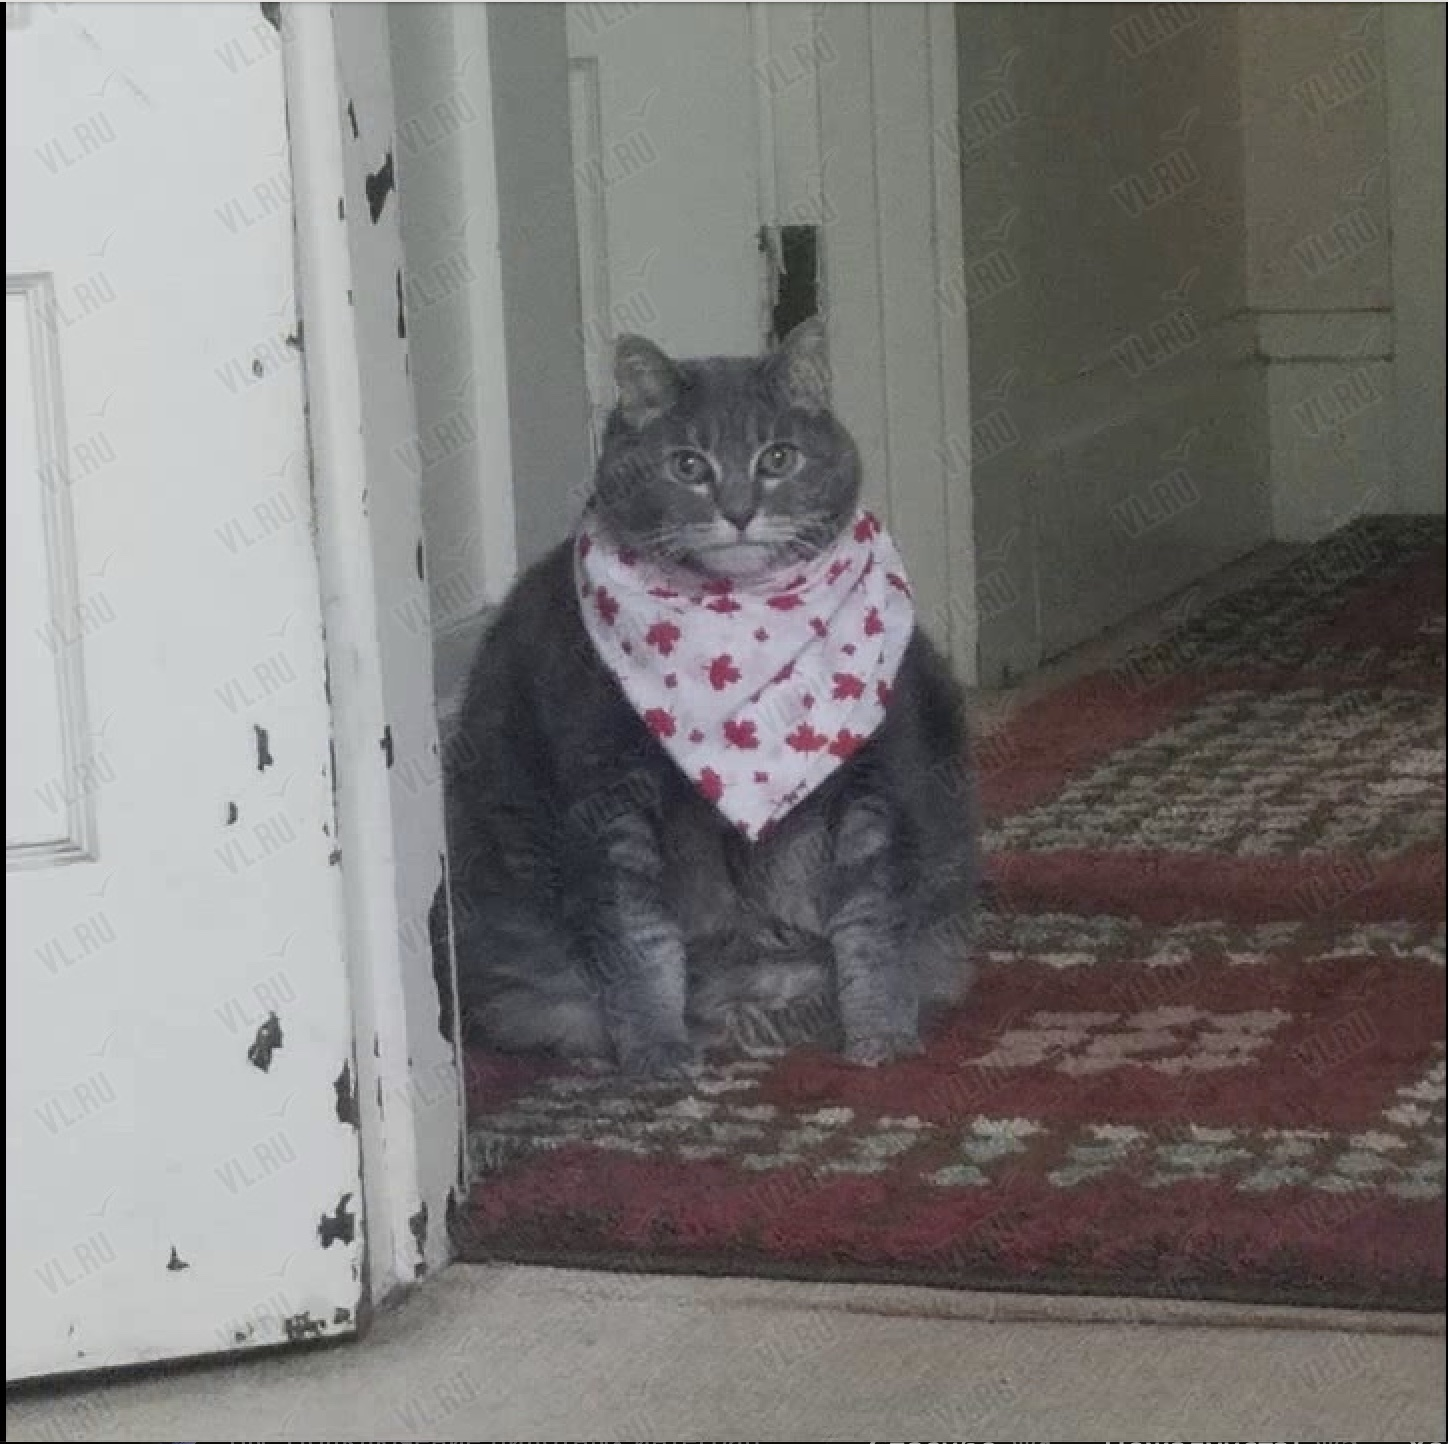Что изображено на этой фотографии? На фотографии изображен серый кот, сидящий на ковре. На шее у кота повязан белый платок с красными рисунками в виде кленовых листьев. Что изображено на этой фотографии? На фотографии изображен серый кот, сидящий на ковре. У кота на шее повязан белый платок с красными рисунками в виде кленовых листьев. Кот находится в помещении, рядом с дверным проемом. 